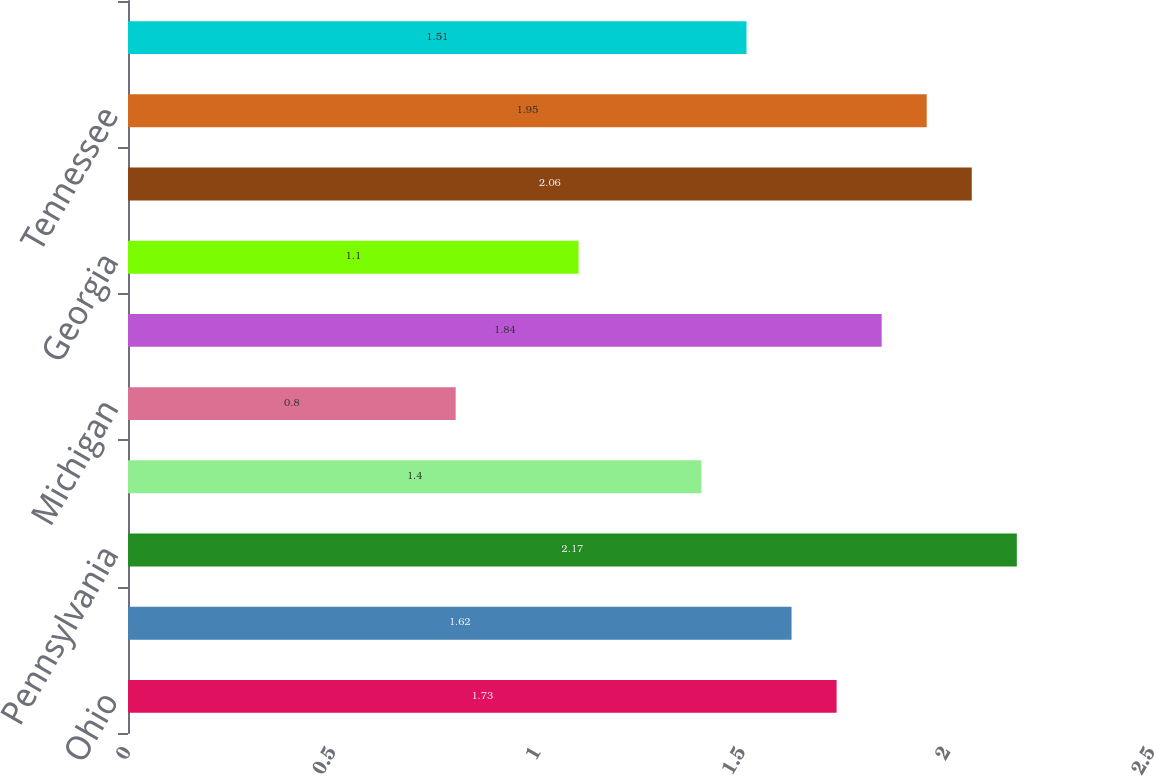<chart> <loc_0><loc_0><loc_500><loc_500><bar_chart><fcel>Ohio<fcel>Illinois<fcel>Pennsylvania<fcel>Indiana<fcel>Michigan<fcel>Virginia<fcel>Georgia<fcel>Wisconsin<fcel>Tennessee<fcel>North Carolina<nl><fcel>1.73<fcel>1.62<fcel>2.17<fcel>1.4<fcel>0.8<fcel>1.84<fcel>1.1<fcel>2.06<fcel>1.95<fcel>1.51<nl></chart> 